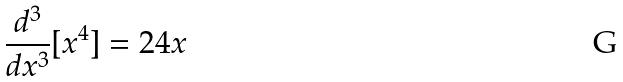Convert formula to latex. <formula><loc_0><loc_0><loc_500><loc_500>\frac { d ^ { 3 } } { d x ^ { 3 } } [ x ^ { 4 } ] = 2 4 x</formula> 